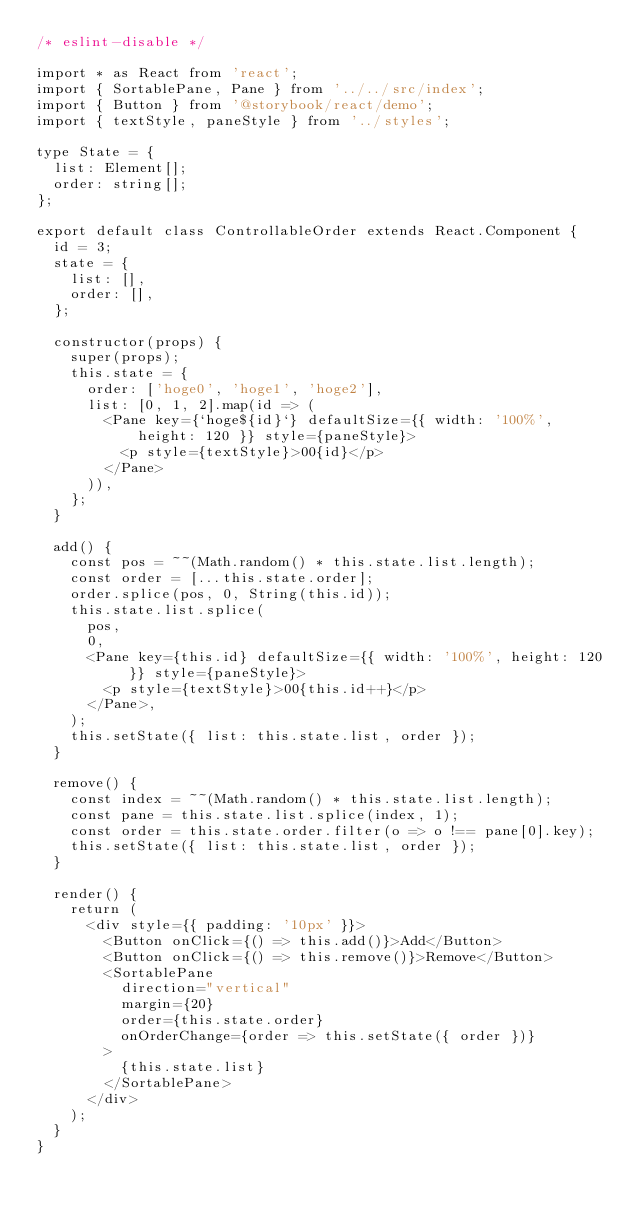<code> <loc_0><loc_0><loc_500><loc_500><_TypeScript_>/* eslint-disable */

import * as React from 'react';
import { SortablePane, Pane } from '../../src/index';
import { Button } from '@storybook/react/demo';
import { textStyle, paneStyle } from '../styles';

type State = {
  list: Element[];
  order: string[];
};

export default class ControllableOrder extends React.Component {
  id = 3;
  state = {
    list: [],
    order: [],
  };

  constructor(props) {
    super(props);
    this.state = {
      order: ['hoge0', 'hoge1', 'hoge2'],
      list: [0, 1, 2].map(id => (
        <Pane key={`hoge${id}`} defaultSize={{ width: '100%', height: 120 }} style={paneStyle}>
          <p style={textStyle}>00{id}</p>
        </Pane>
      )),
    };
  }

  add() {
    const pos = ~~(Math.random() * this.state.list.length);
    const order = [...this.state.order];
    order.splice(pos, 0, String(this.id));
    this.state.list.splice(
      pos,
      0,
      <Pane key={this.id} defaultSize={{ width: '100%', height: 120 }} style={paneStyle}>
        <p style={textStyle}>00{this.id++}</p>
      </Pane>,
    );
    this.setState({ list: this.state.list, order });
  }

  remove() {
    const index = ~~(Math.random() * this.state.list.length);
    const pane = this.state.list.splice(index, 1);
    const order = this.state.order.filter(o => o !== pane[0].key);
    this.setState({ list: this.state.list, order });
  }

  render() {
    return (
      <div style={{ padding: '10px' }}>
        <Button onClick={() => this.add()}>Add</Button>
        <Button onClick={() => this.remove()}>Remove</Button>
        <SortablePane
          direction="vertical"
          margin={20}
          order={this.state.order}
          onOrderChange={order => this.setState({ order })}
        >
          {this.state.list}
        </SortablePane>
      </div>
    );
  }
}
</code> 